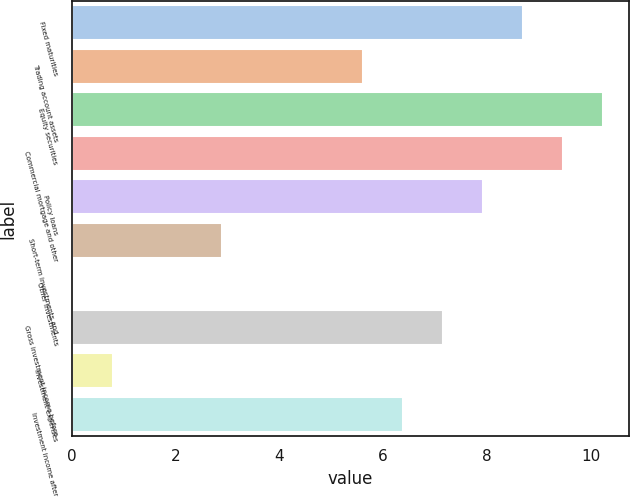Convert chart. <chart><loc_0><loc_0><loc_500><loc_500><bar_chart><fcel>Fixed maturities<fcel>Trading account assets<fcel>Equity securities<fcel>Commercial mortgage and other<fcel>Policy loans<fcel>Short-term investments and<fcel>Other investments<fcel>Gross investment income before<fcel>Investment expenses<fcel>Investment income after<nl><fcel>8.69<fcel>5.61<fcel>10.23<fcel>9.46<fcel>7.92<fcel>2.89<fcel>0.03<fcel>7.15<fcel>0.8<fcel>6.38<nl></chart> 